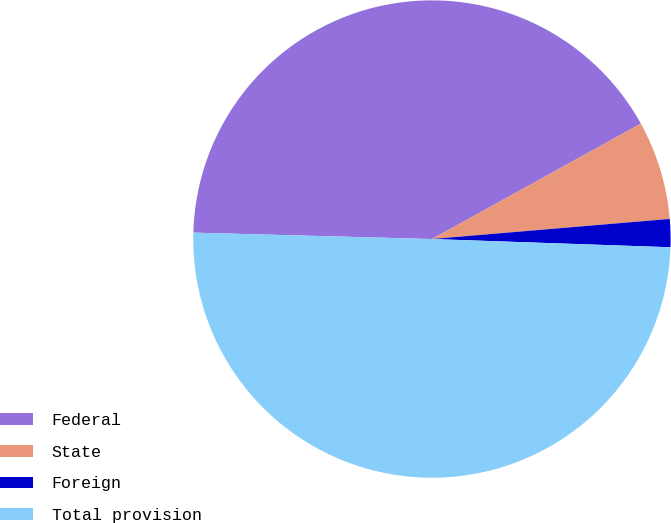<chart> <loc_0><loc_0><loc_500><loc_500><pie_chart><fcel>Federal<fcel>State<fcel>Foreign<fcel>Total provision<nl><fcel>41.54%<fcel>6.69%<fcel>1.89%<fcel>49.88%<nl></chart> 